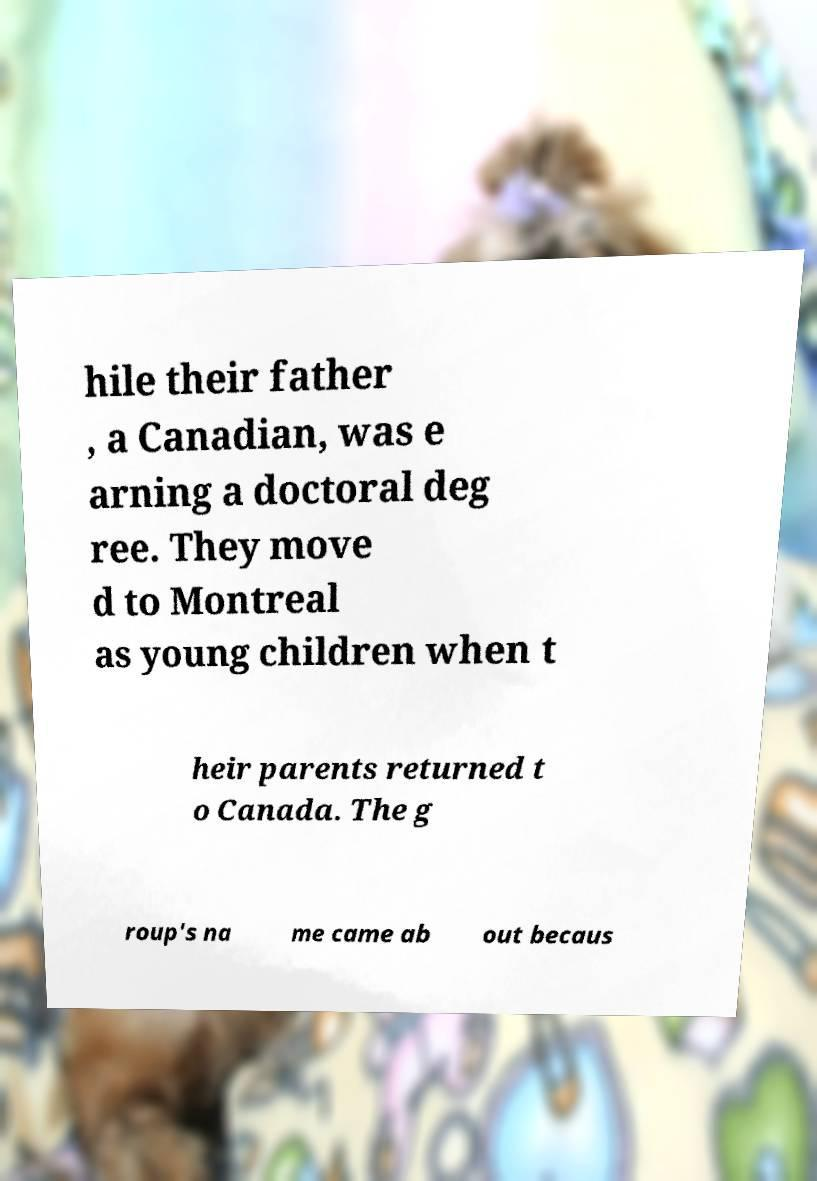Please read and relay the text visible in this image. What does it say? hile their father , a Canadian, was e arning a doctoral deg ree. They move d to Montreal as young children when t heir parents returned t o Canada. The g roup's na me came ab out becaus 